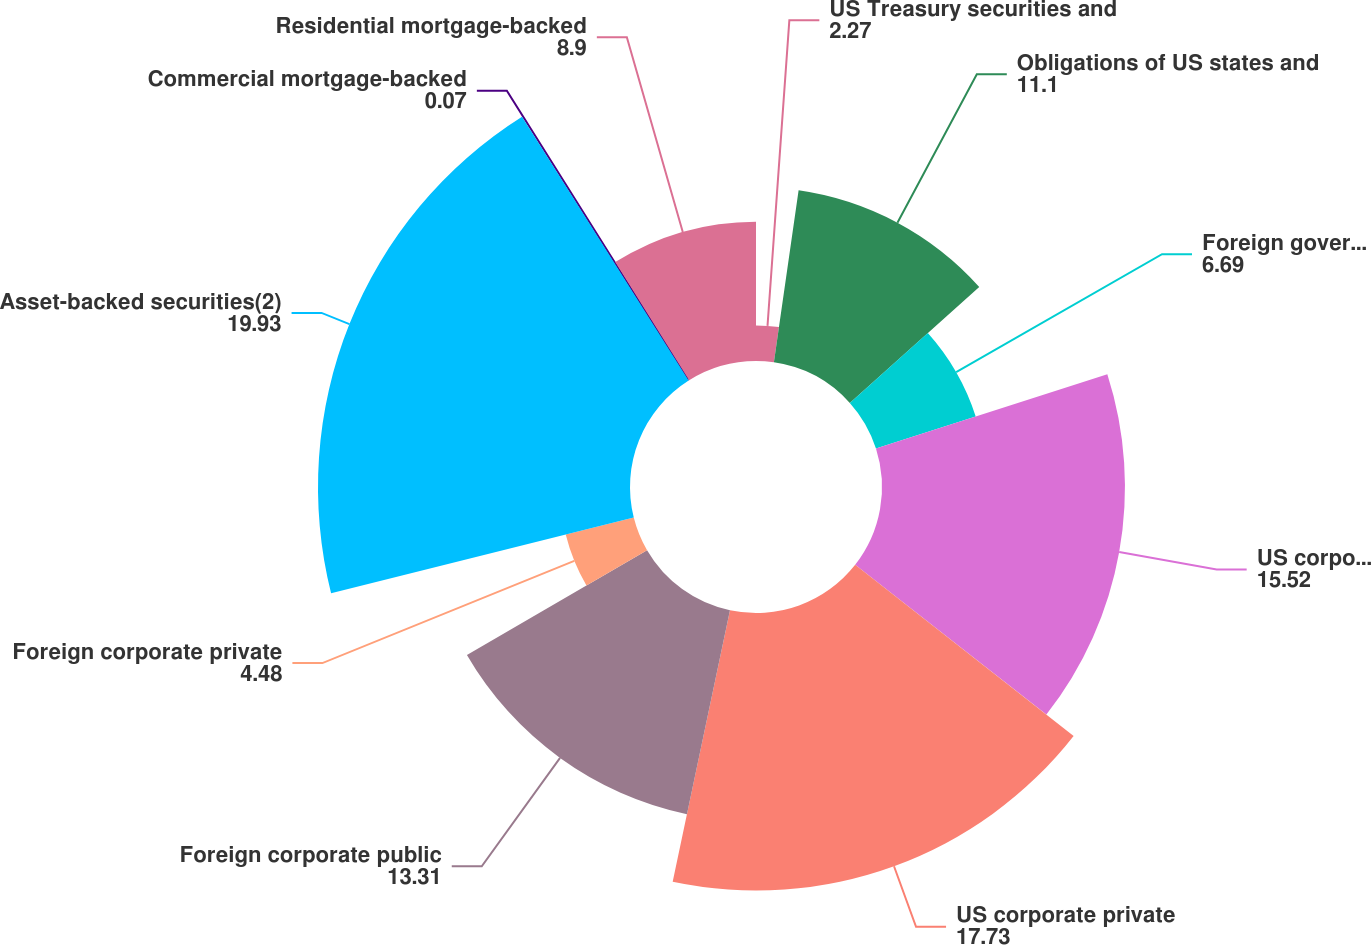Convert chart to OTSL. <chart><loc_0><loc_0><loc_500><loc_500><pie_chart><fcel>US Treasury securities and<fcel>Obligations of US states and<fcel>Foreign government bonds<fcel>US corporate public securities<fcel>US corporate private<fcel>Foreign corporate public<fcel>Foreign corporate private<fcel>Asset-backed securities(2)<fcel>Commercial mortgage-backed<fcel>Residential mortgage-backed<nl><fcel>2.27%<fcel>11.1%<fcel>6.69%<fcel>15.52%<fcel>17.73%<fcel>13.31%<fcel>4.48%<fcel>19.93%<fcel>0.07%<fcel>8.9%<nl></chart> 